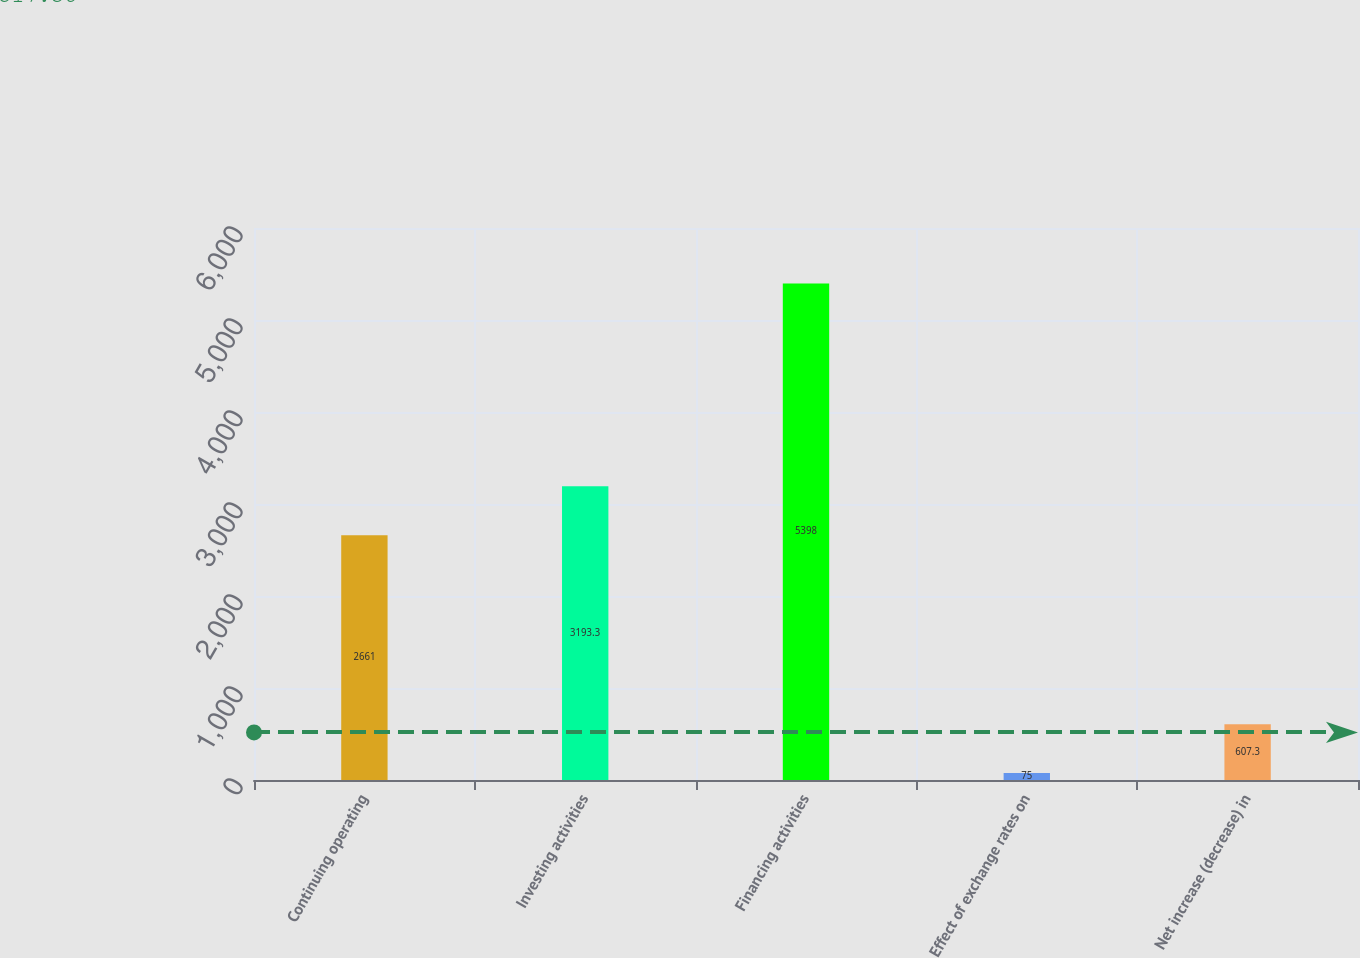<chart> <loc_0><loc_0><loc_500><loc_500><bar_chart><fcel>Continuing operating<fcel>Investing activities<fcel>Financing activities<fcel>Effect of exchange rates on<fcel>Net increase (decrease) in<nl><fcel>2661<fcel>3193.3<fcel>5398<fcel>75<fcel>607.3<nl></chart> 